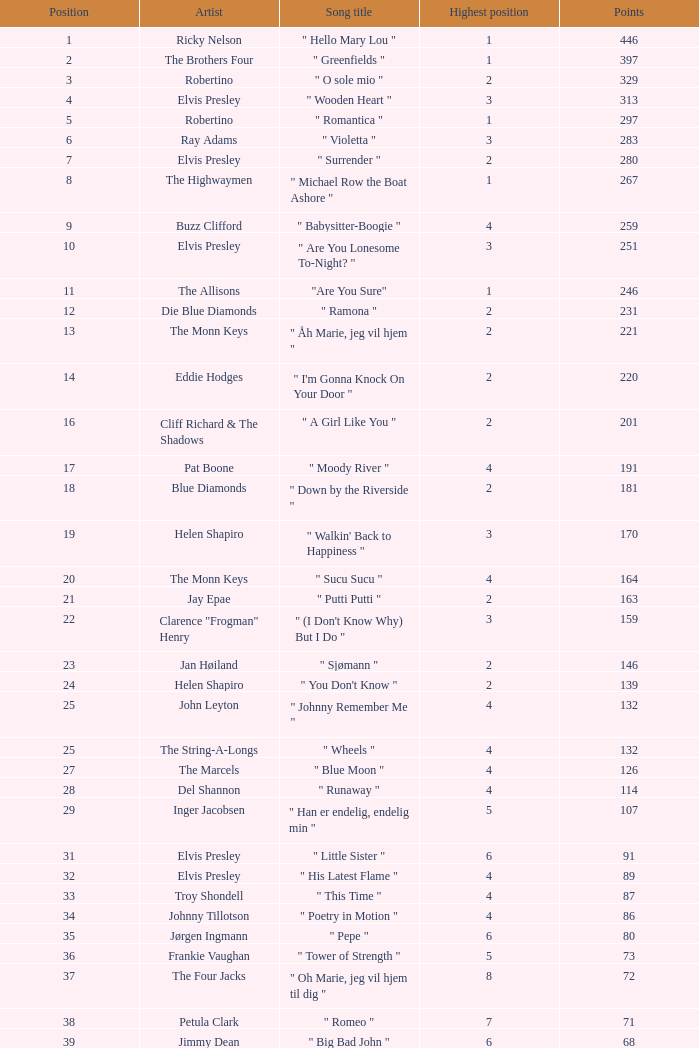What is highest place reached by artist Ray Adams? 6.0. 